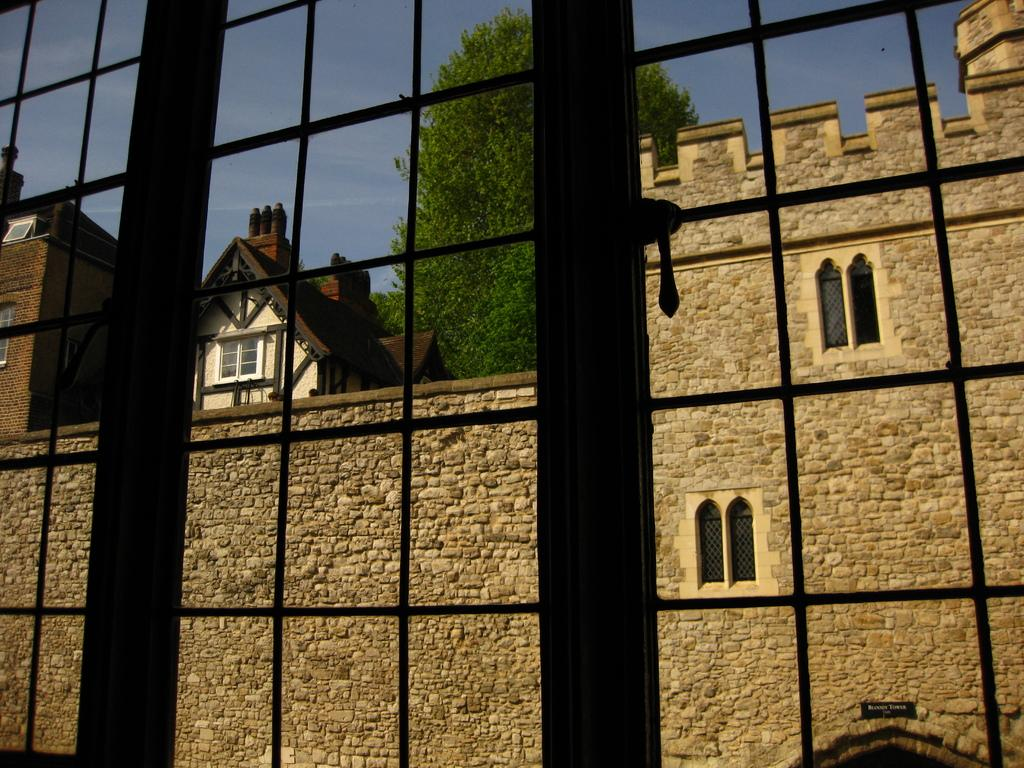What is the main subject of the image? The main subject of the image is bars. What can be seen in the background of the image? There are buildings and a tree in the background of the image. What is visible above the buildings and tree? The sky is visible in the background of the image. How many bats are hanging from the bars in the image? There are no bats present in the image; it only features bars and a background with buildings, a tree, and the sky. 